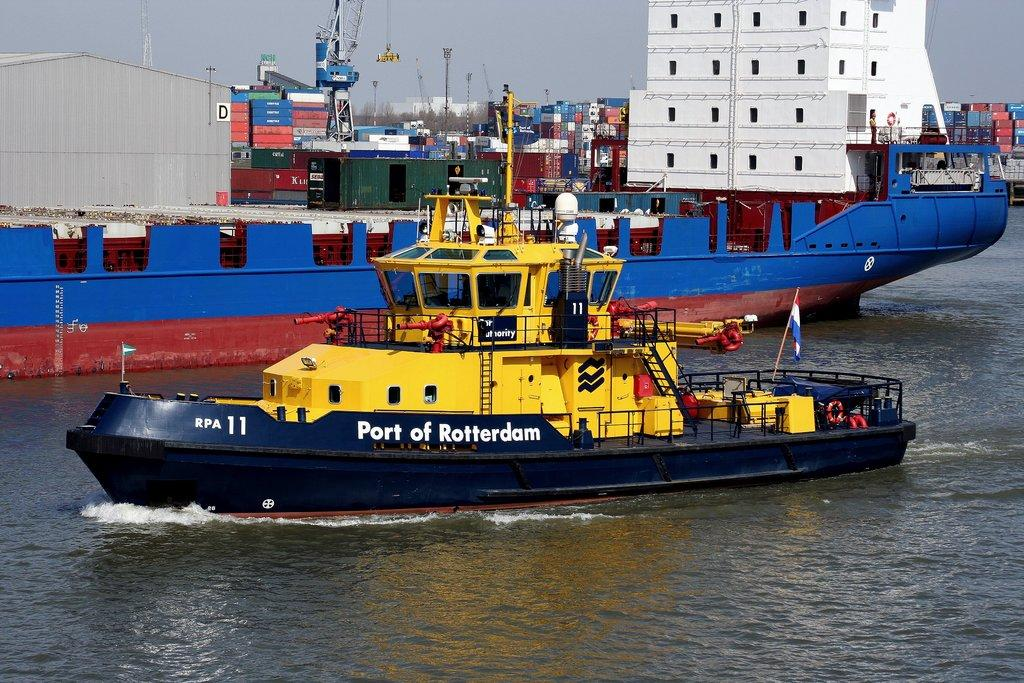What is on the water in the image? There are ships on the water in the image. What can be seen in the background of the image? In the background of the image, there are containers, cranes, buildings, and trees. Where are the chickens located in the image? There are no chickens present in the image. What type of club can be seen in the image? There is no club present in the image. 